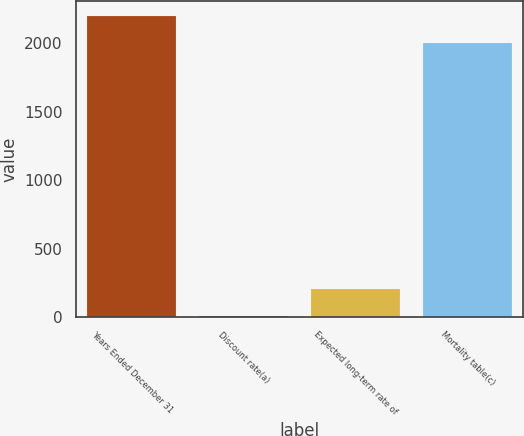Convert chart. <chart><loc_0><loc_0><loc_500><loc_500><bar_chart><fcel>Years Ended December 31<fcel>Discount rate(a)<fcel>Expected long-term rate of<fcel>Mortality table(c)<nl><fcel>2200.06<fcel>6.4<fcel>206.46<fcel>2000<nl></chart> 